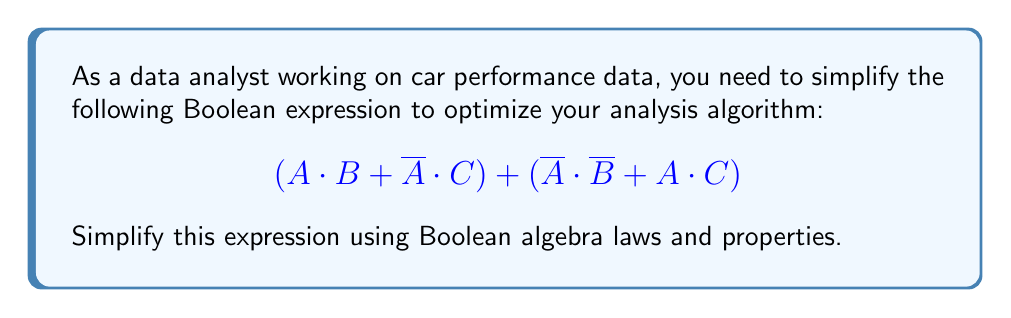Solve this math problem. Let's simplify this expression step by step:

1) First, let's distribute the OR operation over the two parentheses:
   $$(A \cdot B + \overline{A} \cdot C) + (\overline{A} \cdot \overline{B} + A \cdot C)$$

2) Now, we can rearrange the terms using the commutative property:
   $$(A \cdot B + A \cdot C) + (\overline{A} \cdot C + \overline{A} \cdot \overline{B})$$

3) We can factor out A and $\overline{A}$ from each parenthesis:
   $$(A \cdot (B + C)) + (\overline{A} \cdot (C + \overline{B}))$$

4) Notice that $(C + \overline{B})$ is equivalent to $(B + C)$ due to the commutative property of OR. So we can rewrite this as:
   $$(A \cdot (B + C)) + (\overline{A} \cdot (B + C))$$

5) Now we can factor out $(B + C)$:
   $$(A + \overline{A}) \cdot (B + C)$$

6) $(A + \overline{A})$ is always true (1) according to the law of excluded middle:
   $$1 \cdot (B + C)$$

7) And 1 is the identity element for AND:
   $$(B + C)$$

Thus, we have simplified the expression to $(B + C)$.
Answer: $B + C$ 